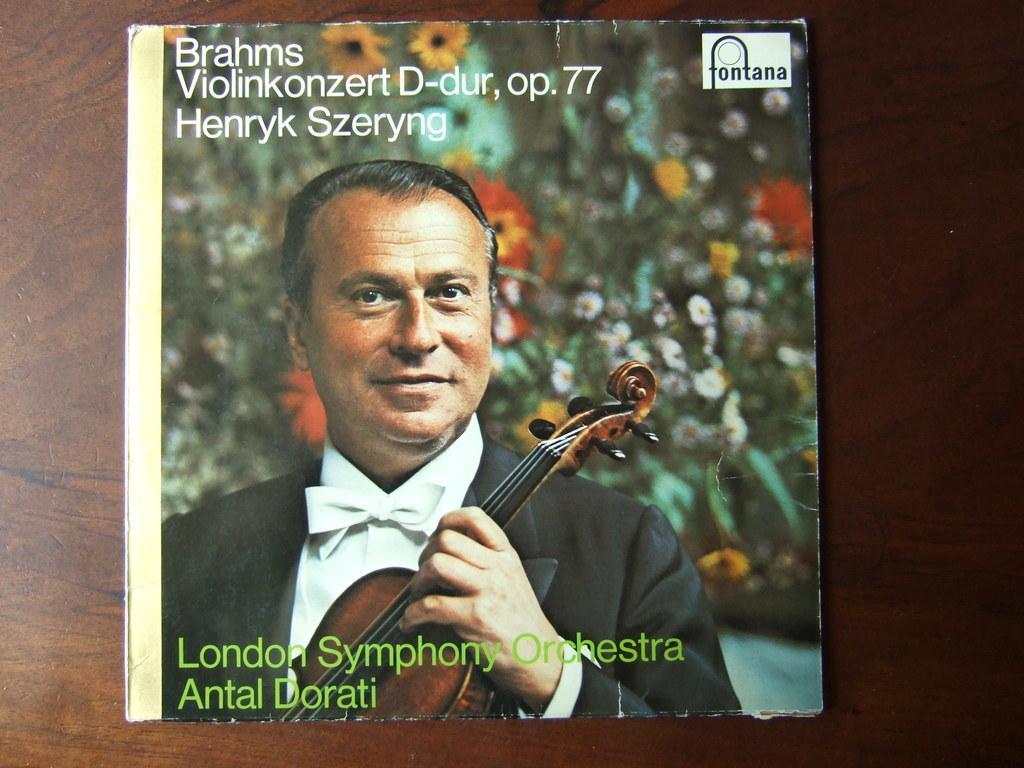Can you describe this image briefly? There is a poster in which, there is a person in a coat, holding a violin with one hand. In the background, there are flowers. And there are texts and a watermark on the poster. This poster is on the wooden table. 